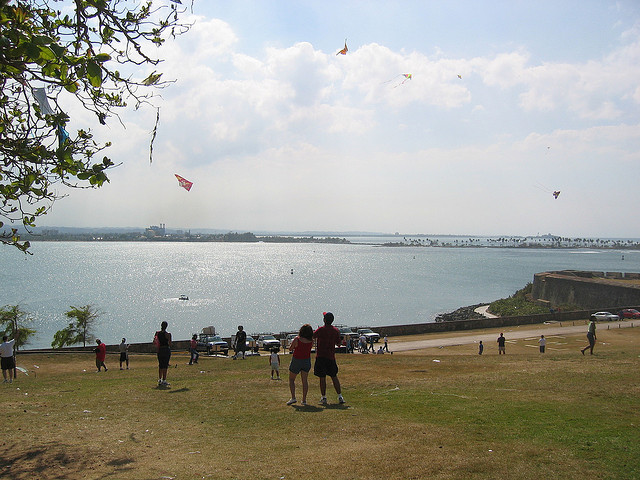<image>What color are the flowers? There are no flowers in the image. What color are the flowers? There are no flowers shown in the image. 